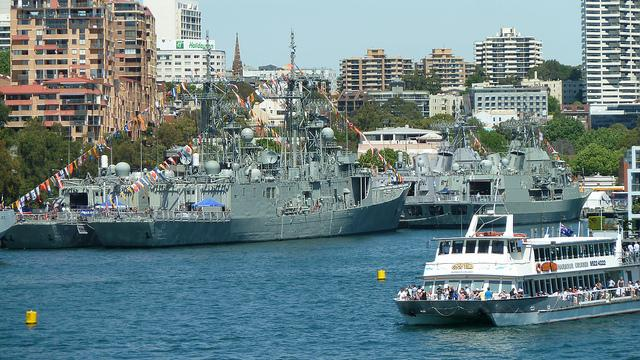What vehicle used for this water transportation? Please explain your reasoning. cargo ship. Cargo ships are massive enough to account for the size of this water transportation. 